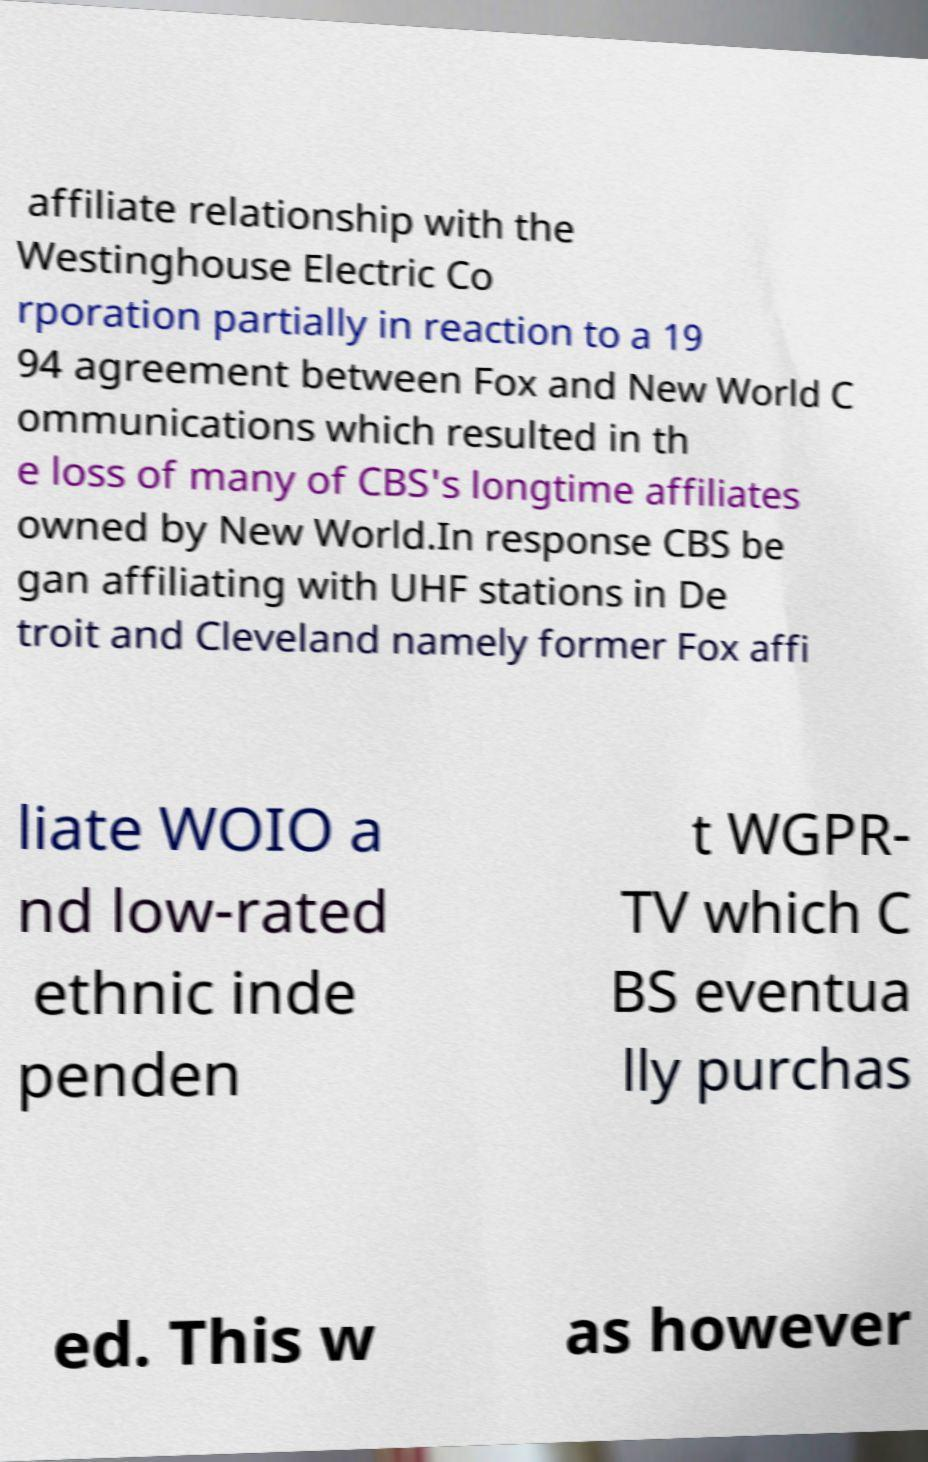Can you accurately transcribe the text from the provided image for me? affiliate relationship with the Westinghouse Electric Co rporation partially in reaction to a 19 94 agreement between Fox and New World C ommunications which resulted in th e loss of many of CBS's longtime affiliates owned by New World.In response CBS be gan affiliating with UHF stations in De troit and Cleveland namely former Fox affi liate WOIO a nd low-rated ethnic inde penden t WGPR- TV which C BS eventua lly purchas ed. This w as however 